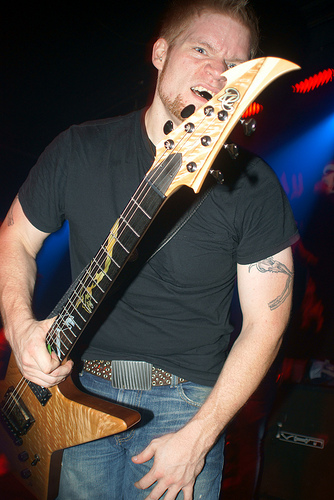<image>
Can you confirm if the guitar is in front of the person? Yes. The guitar is positioned in front of the person, appearing closer to the camera viewpoint. 